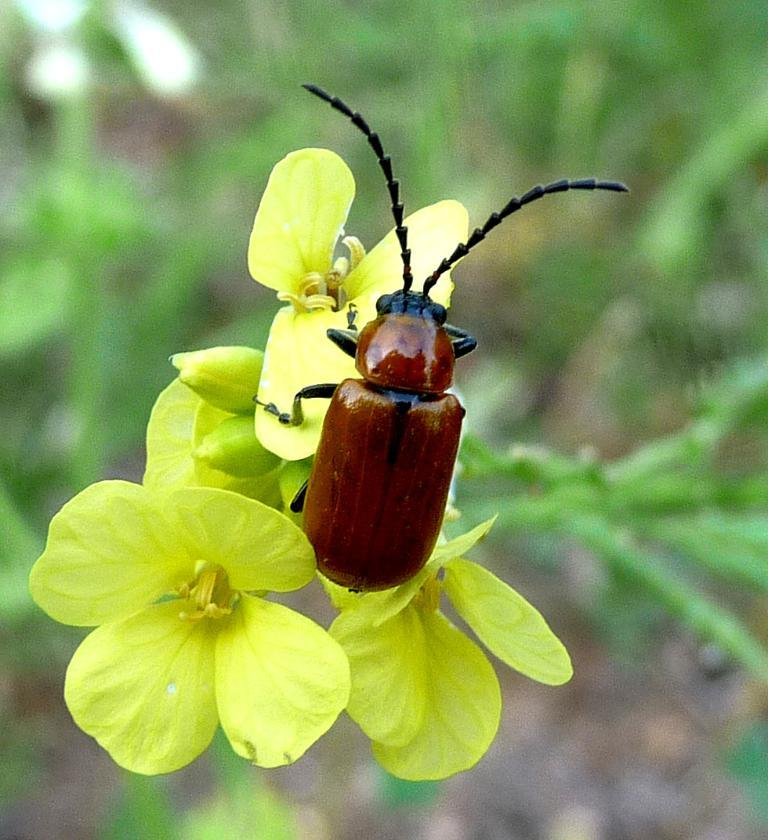What is on the flower in the image? There is a bug on a flower in the image. What can be seen on the left side of the bug? There are buds and flowers on the left side of the bug. How would you describe the background of the image? The background of the image is blurred. How many beds are visible in the image? There are no beds present in the image. What type of humor can be seen in the image? There is no humor depicted in the image; it features a bug on a flower. 